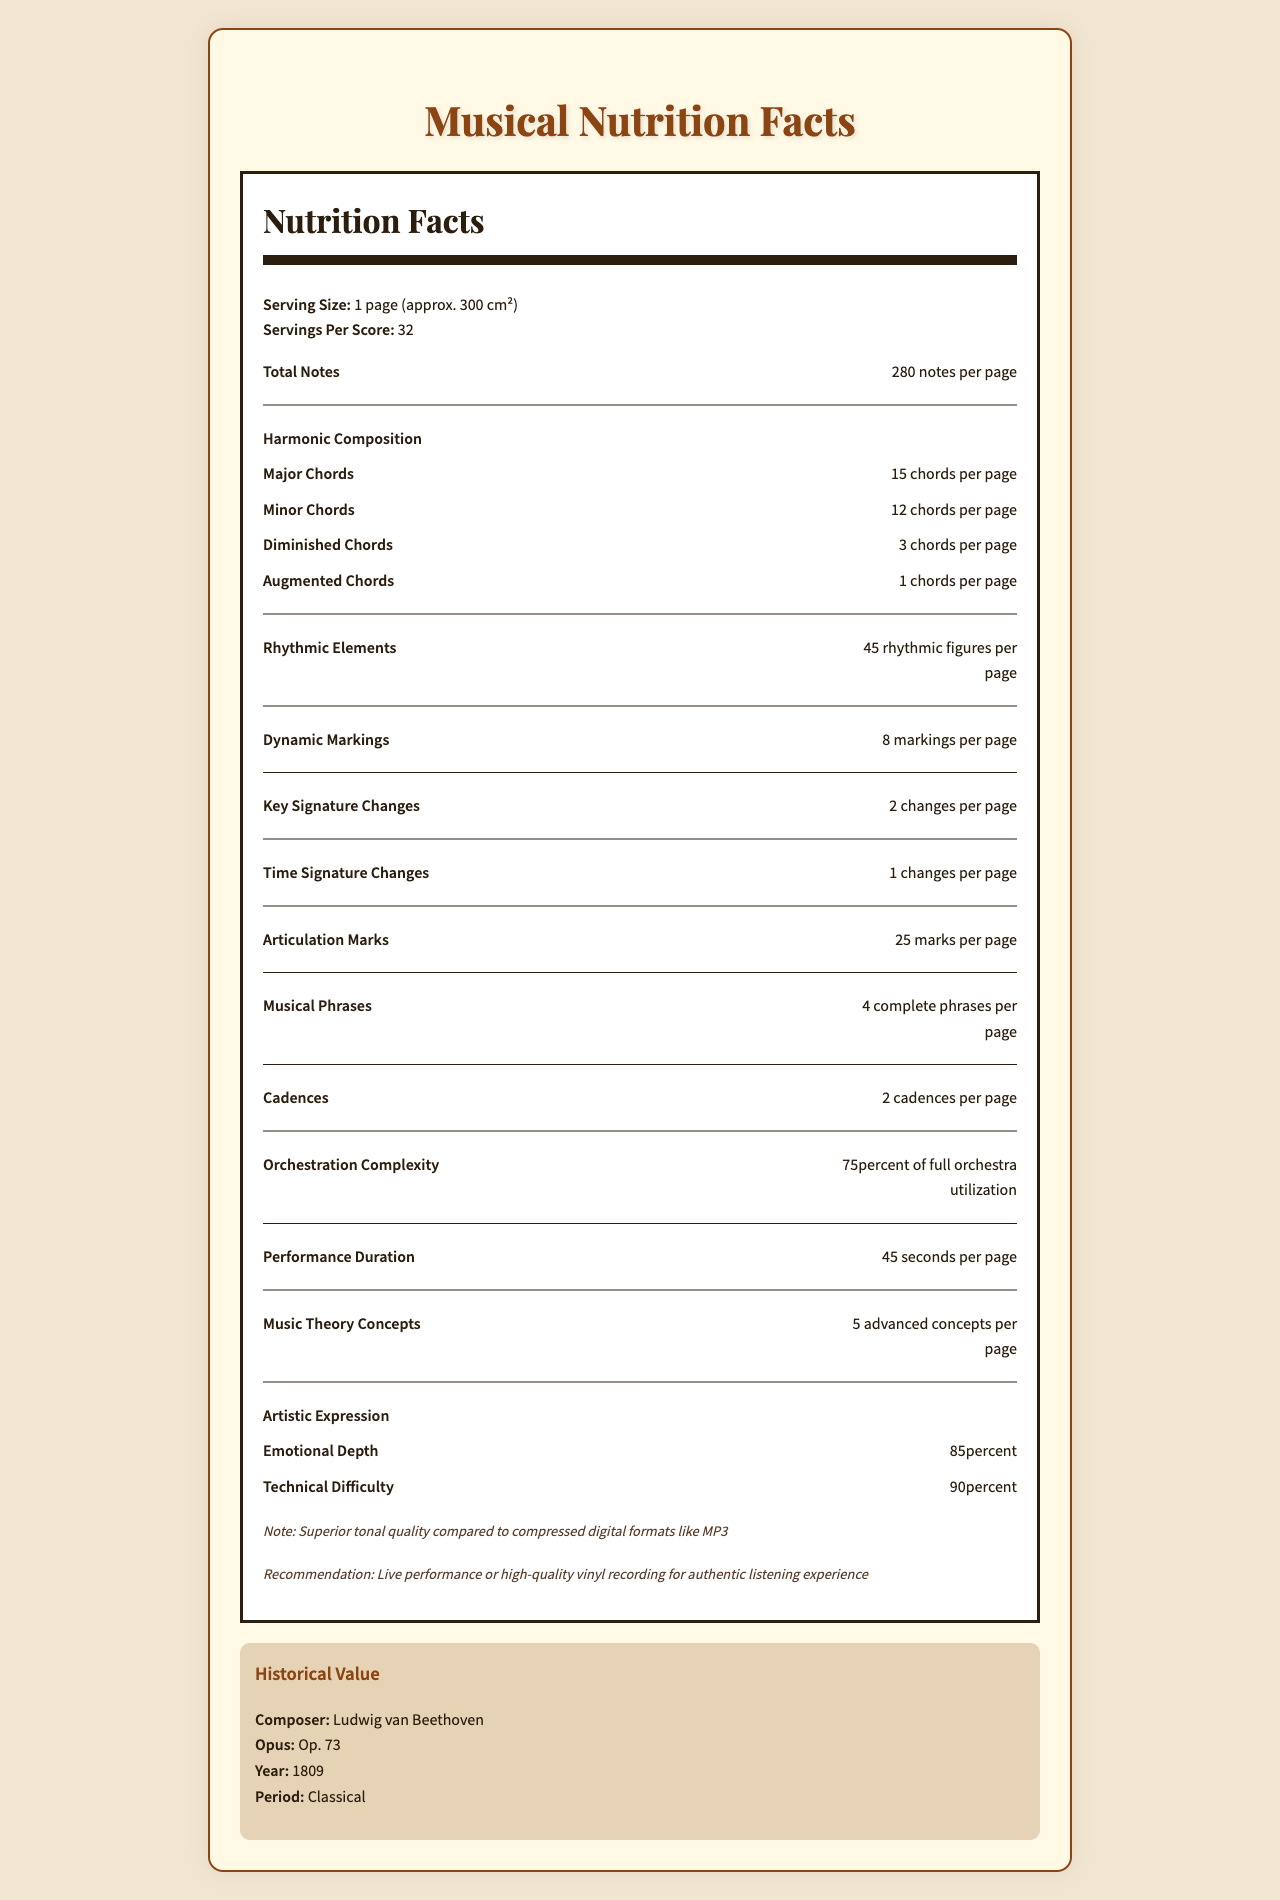what is the total number of notes per page? The document states "Total Notes: 280 notes per page."
Answer: 280 notes how many major chords are there per page? The section on harmonic composition lists "Major Chords: 15 chords per page."
Answer: 15 major chords how many different types of chords are there per page? The harmonic composition section details major, minor, diminished, and augmented chords.
Answer: 4 types (major, minor, diminished, augmented) how many key signature changes occur per page? The document states under key signatures, "Total: 2 changes per page."
Answer: 2 changes what percentage of the page does the development section occupy in thematic material? The thematic material section lists "Development: 40% of page."
Answer: 40% how many cadences are there per page? A. 1 B. 2 C. 3 D. 4 The cadences section states "Total: 2 cadences per page."
Answer: B what is the performance duration of the sheet music per page? A. 30 seconds B. 60 seconds C. 45 seconds D. 75 seconds The performance duration section lists "Total: 45 seconds per page."
Answer: C is the paper quality of the sheet music archival grade? The preservation notes section states "Paper Quality: Acid-free, archival grade."
Answer: Yes summarize the main details of the musical nutrition facts label. The document serves as a comprehensive analysis of a piano concerto, highlighting its structure, complexity, emotional depth, and historical context.
Answer: It provides a detailed breakdown of various musical elements in a piano concerto such as notes, chords, rhythmic figures, dynamic markings, key and time signature changes, articulation marks, musical phrases, cadences, and thematic material. Additionally, it includes information on orchestration complexity, performance duration, artistic expression, preservation notes, and a comparison with audio quality. Historical details about the composer, opus, year, and period are also given. what types of ink are recommended for storage? The document contains information about the preservation of the sheet music but does not specify ink types recommended for storage.
Answer: Cannot be determined how many articulation marks are there per page? The document states under articulation marks, "Total: 25 marks per page."
Answer: 25 marks 